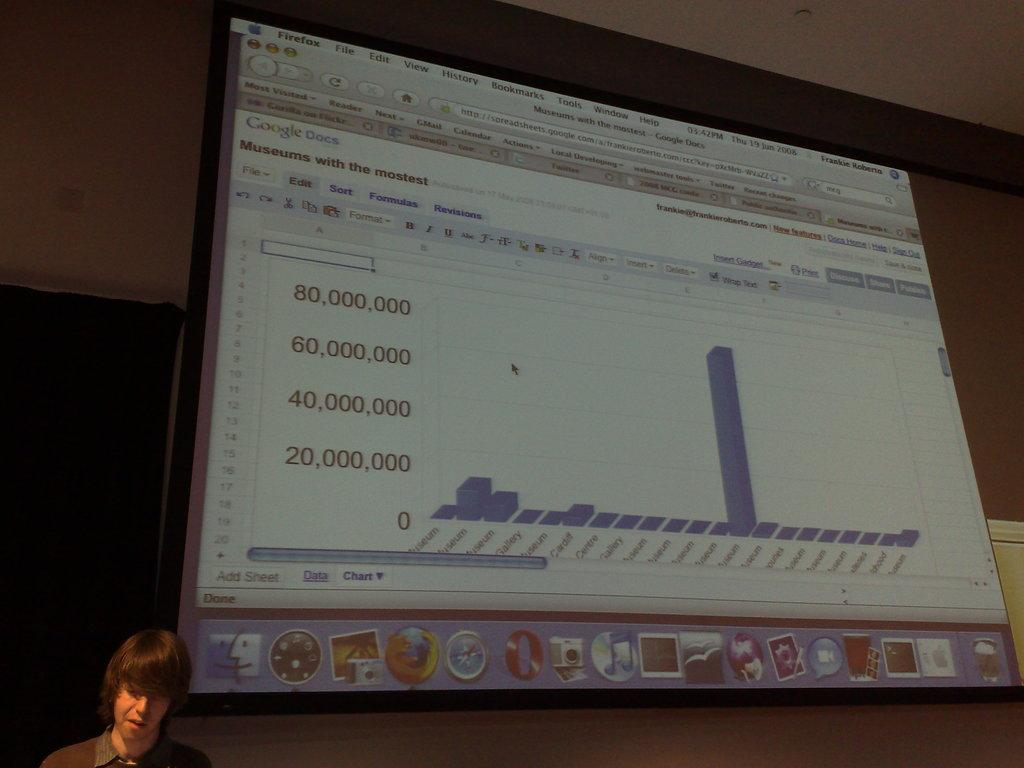Who is present in the image? There is a man in the image. What can be seen in the background of the image? There is a screen in the background of the image. What is displayed on the screen? There is a presentation visible on the screen. What type of joke can be heard coming from the man's ear in the image? There is no joke or ear visible in the image; it only features a man and a screen with a presentation. 